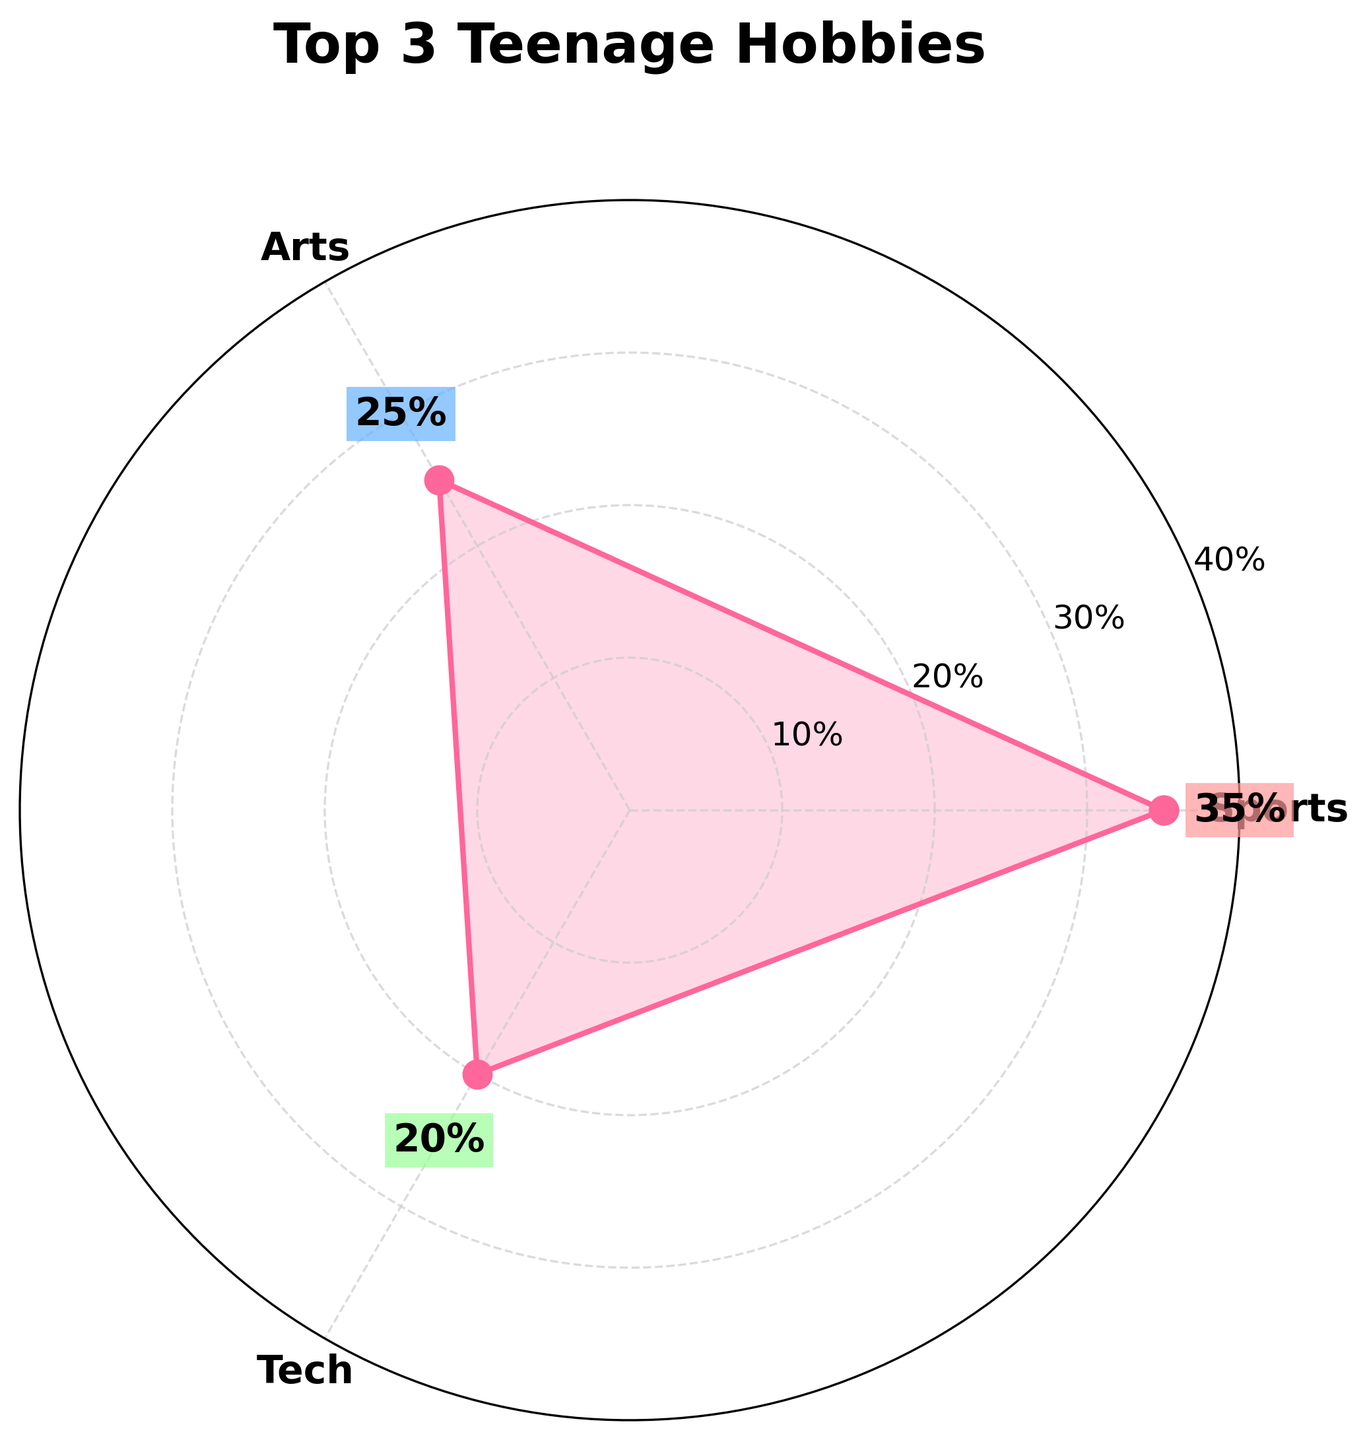How many categories are represented in the chart? The chart displays three segments, each representing a different category.
Answer: 3 Which hobby has the highest percentage? By looking at the chart, the longest segment corresponds to the category with the highest percentage.
Answer: Sports How does the percentage of Tech compare to Social Activities? Both segments for Tech and Social Activities are depicted with roughly equal length, indicating they have the same percentage.
Answer: They are equal What is the percentage difference between Sports and Arts? Sports has a percentage of 35% and Arts has 25%. Subtracting 25 from 35 gives us the difference.
Answer: 10% Which category is represented with a green label next to its segment? Based on the color coding, the green label corresponds to Tech.
Answer: Tech If you add the percentages of Arts and Tech, what do you get? Arts has 25% and Tech has 20%. Adding these values (25 + 20) gives us the result.
Answer: 45% What is the range of percentages shown on the radial axis? The radial axis has tick marks ranging from 10% to 40%.
Answer: 10% to 40% Which category's label appears closest to the top of the plot? The label closest to the top of the plot corresponds to Sports.
Answer: Sports If the total number of teenagers is 100, how many of them are interested in Sports? 35% of 100 is calculated by multiplying 100 by 0.35.
Answer: 35 Are there any labels with the same exact percentage value? Both Tech and Social Activities are labeled with 20%.
Answer: Yes 